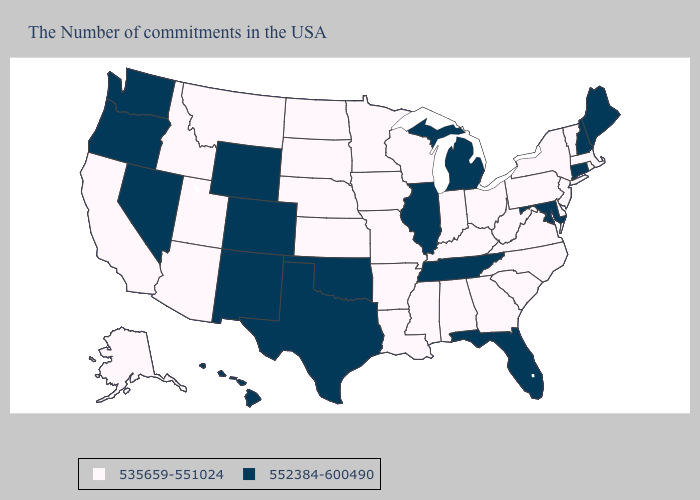What is the value of Alabama?
Answer briefly. 535659-551024. Among the states that border New Hampshire , which have the highest value?
Give a very brief answer. Maine. Name the states that have a value in the range 535659-551024?
Quick response, please. Massachusetts, Rhode Island, Vermont, New York, New Jersey, Delaware, Pennsylvania, Virginia, North Carolina, South Carolina, West Virginia, Ohio, Georgia, Kentucky, Indiana, Alabama, Wisconsin, Mississippi, Louisiana, Missouri, Arkansas, Minnesota, Iowa, Kansas, Nebraska, South Dakota, North Dakota, Utah, Montana, Arizona, Idaho, California, Alaska. Does New Hampshire have the lowest value in the Northeast?
Quick response, please. No. Name the states that have a value in the range 535659-551024?
Write a very short answer. Massachusetts, Rhode Island, Vermont, New York, New Jersey, Delaware, Pennsylvania, Virginia, North Carolina, South Carolina, West Virginia, Ohio, Georgia, Kentucky, Indiana, Alabama, Wisconsin, Mississippi, Louisiana, Missouri, Arkansas, Minnesota, Iowa, Kansas, Nebraska, South Dakota, North Dakota, Utah, Montana, Arizona, Idaho, California, Alaska. What is the highest value in states that border Montana?
Keep it brief. 552384-600490. Does the map have missing data?
Short answer required. No. What is the value of Florida?
Keep it brief. 552384-600490. How many symbols are there in the legend?
Write a very short answer. 2. What is the value of Michigan?
Give a very brief answer. 552384-600490. Does the map have missing data?
Write a very short answer. No. Which states have the highest value in the USA?
Write a very short answer. Maine, New Hampshire, Connecticut, Maryland, Florida, Michigan, Tennessee, Illinois, Oklahoma, Texas, Wyoming, Colorado, New Mexico, Nevada, Washington, Oregon, Hawaii. What is the lowest value in the Northeast?
Write a very short answer. 535659-551024. Name the states that have a value in the range 535659-551024?
Be succinct. Massachusetts, Rhode Island, Vermont, New York, New Jersey, Delaware, Pennsylvania, Virginia, North Carolina, South Carolina, West Virginia, Ohio, Georgia, Kentucky, Indiana, Alabama, Wisconsin, Mississippi, Louisiana, Missouri, Arkansas, Minnesota, Iowa, Kansas, Nebraska, South Dakota, North Dakota, Utah, Montana, Arizona, Idaho, California, Alaska. Name the states that have a value in the range 552384-600490?
Answer briefly. Maine, New Hampshire, Connecticut, Maryland, Florida, Michigan, Tennessee, Illinois, Oklahoma, Texas, Wyoming, Colorado, New Mexico, Nevada, Washington, Oregon, Hawaii. 